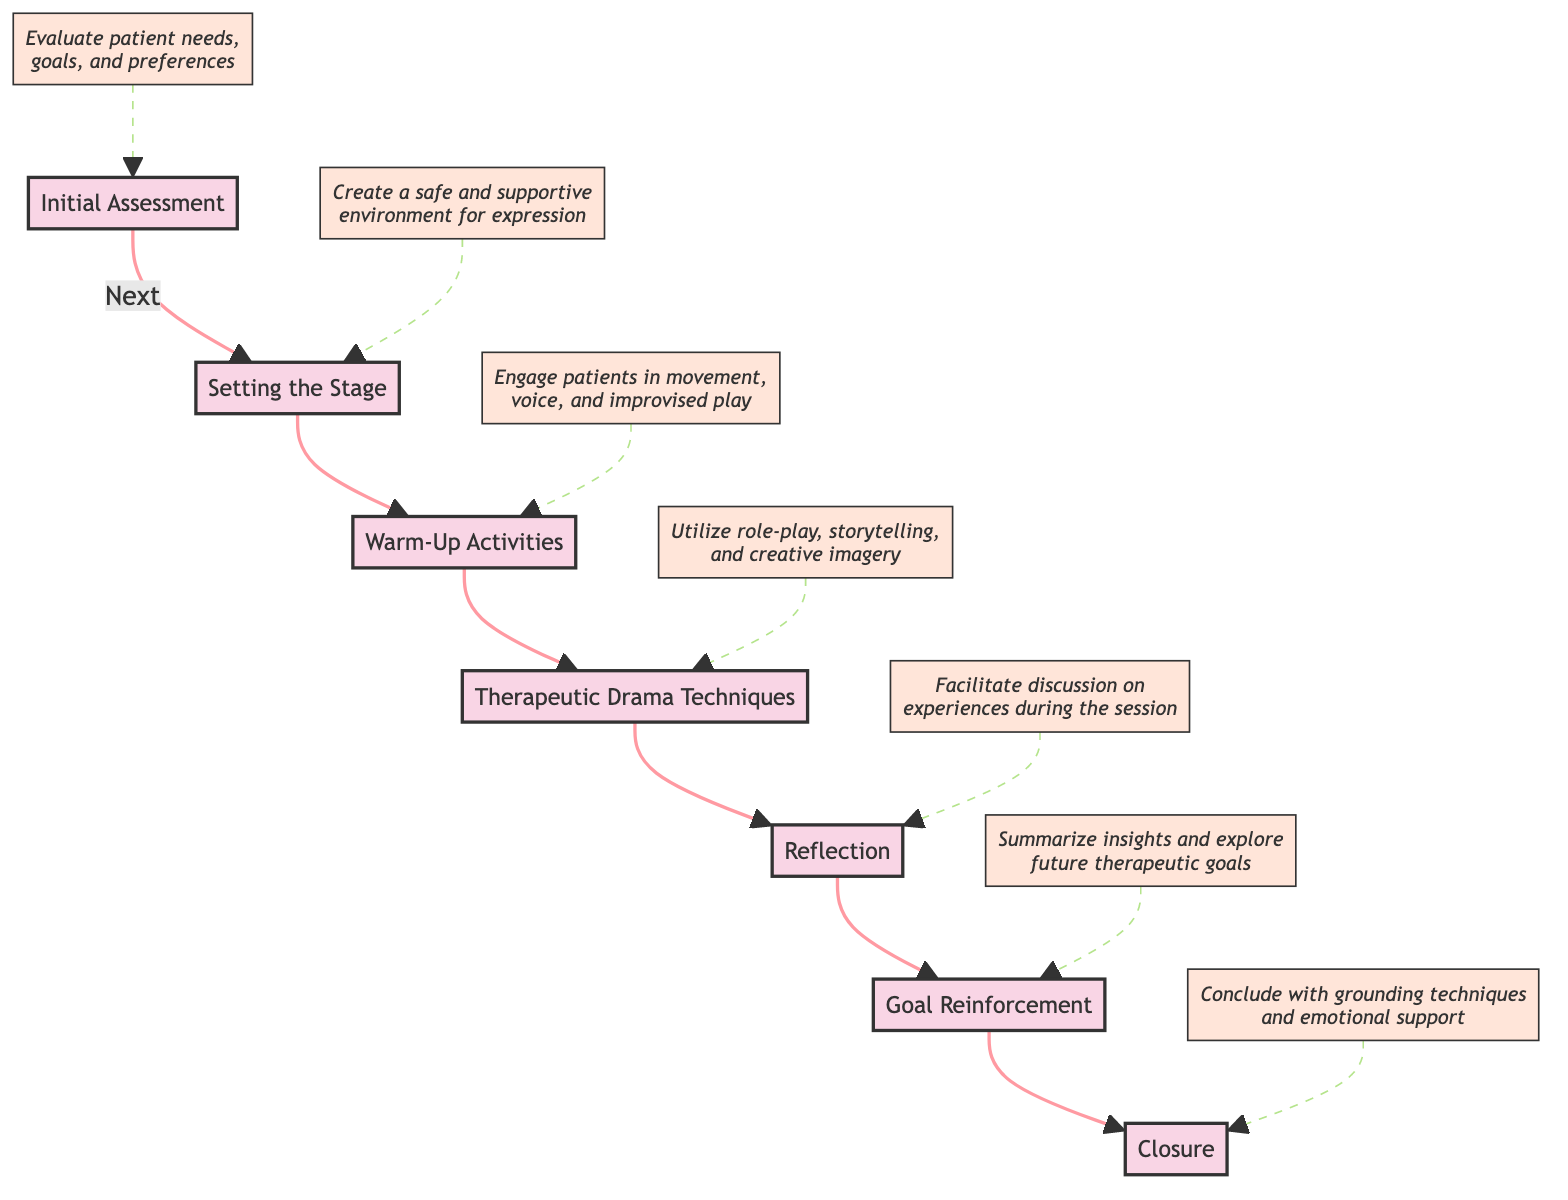What is the first stage of the drama therapy session? The first stage is identified as "Initial Assessment," which evaluates patient needs, goals, and preferences. This is indicated by the flowchart starting point.
Answer: Initial Assessment What follows "Warm-Up Activities"? According to the flow chart, the stage that follows "Warm-Up Activities" is "Therapeutic Drama Techniques," establishing a sequential flow between the two stages.
Answer: Therapeutic Drama Techniques How many stages are there in total? The diagram displays a sequence of six distinct stages, indicating that the therapy process consists of these individual components.
Answer: 7 What is the purpose of "Reflection"? The purpose of "Reflection," as per the diagram, is to facilitate discussion on experiences during the session, providing insight into the therapeutic process that has taken place.
Answer: Facilitate discussion on experiences during the session Which stage utilizes role-play, storytelling, and creative imagery? The flowchart specifies that the stage which utilizes role-play, storytelling, and creative imagery is "Therapeutic Drama Techniques," indicating its function within the overall therapy process.
Answer: Therapeutic Drama Techniques What is the last stage of the drama therapy session? The diagram concludes with the "Closure" stage, which features grounding techniques and emotional support, marking the end of the session.
Answer: Closure Which stage comes before "Goal Reinforcement"? In the sequence provided in the flowchart, "Reflection" is the stage that directly precedes "Goal Reinforcement," demonstrating the flow of activities leading to goal setting.
Answer: Reflection What type of environment is created during "Setting the Stage"? The description in the diagram for "Setting the Stage" states that a safe and supportive environment is created for expression, emphasizing the importance of a comfort zone for patients during therapy.
Answer: Safe and supportive environment for expression 